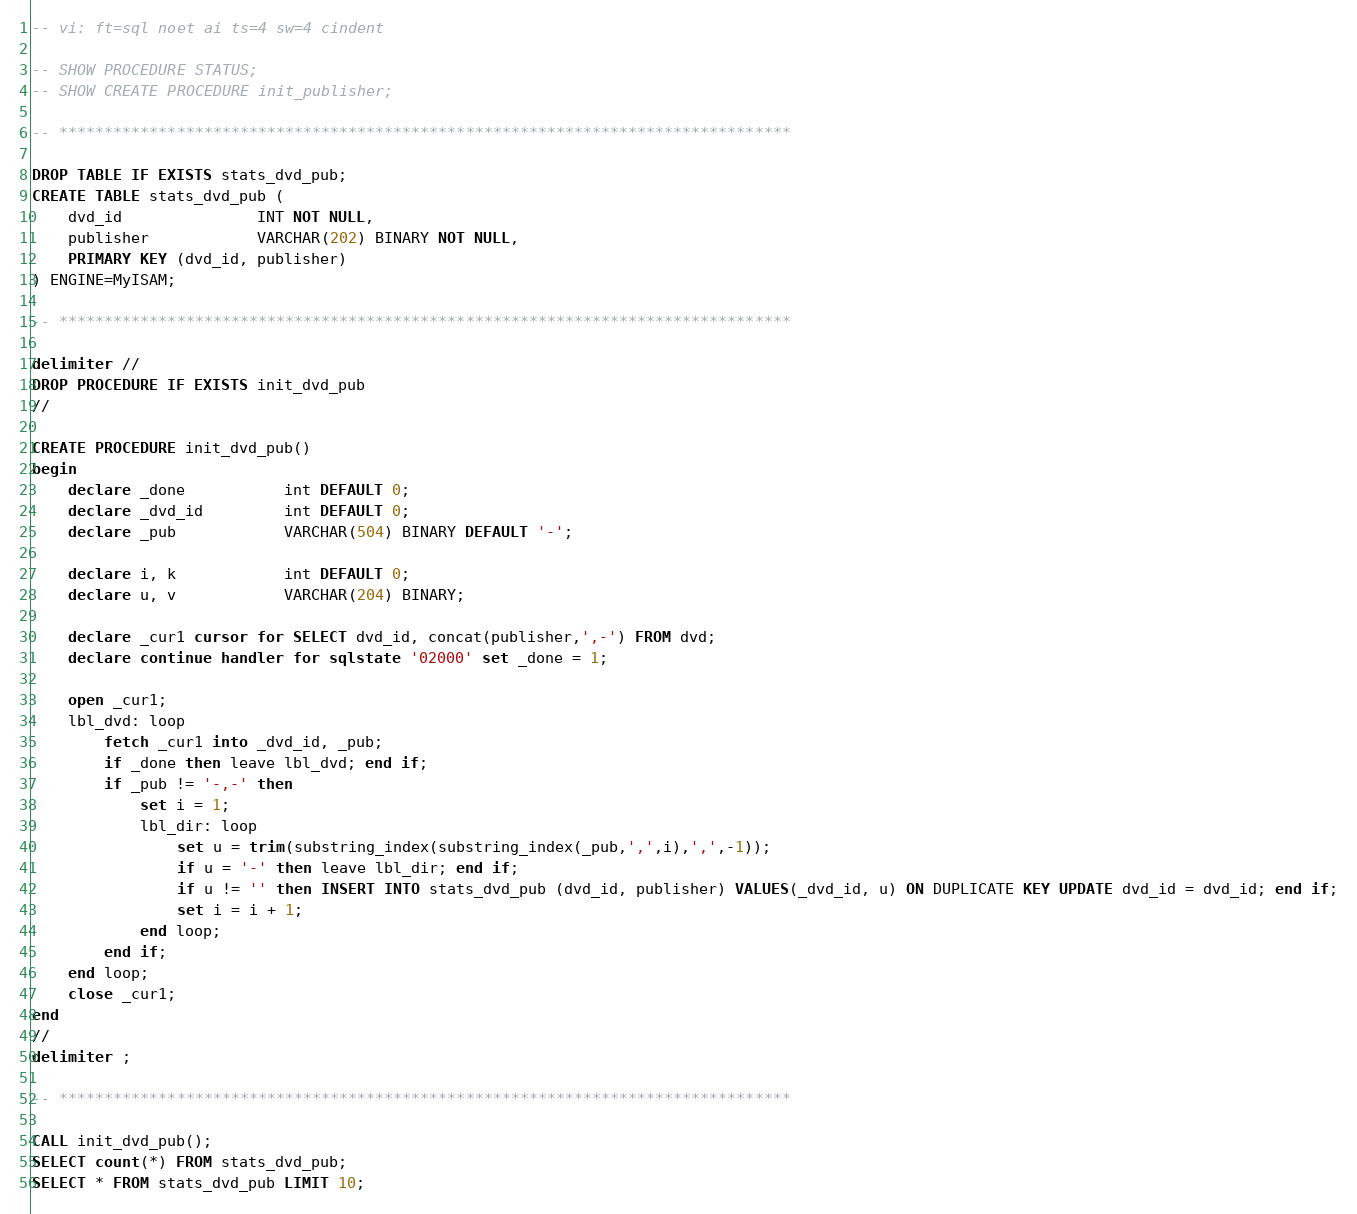Convert code to text. <code><loc_0><loc_0><loc_500><loc_500><_SQL_>-- vi: ft=sql noet ai ts=4 sw=4 cindent

-- SHOW PROCEDURE STATUS;
-- SHOW CREATE PROCEDURE init_publisher;

-- *********************************************************************************

DROP TABLE IF EXISTS stats_dvd_pub;
CREATE TABLE stats_dvd_pub (
    dvd_id               INT NOT NULL,
    publisher            VARCHAR(202) BINARY NOT NULL,
    PRIMARY KEY (dvd_id, publisher)
) ENGINE=MyISAM;

-- *********************************************************************************

delimiter //
DROP PROCEDURE IF EXISTS init_dvd_pub
//

CREATE PROCEDURE init_dvd_pub()
begin
    declare _done           int DEFAULT 0;
    declare _dvd_id         int DEFAULT 0;
    declare _pub            VARCHAR(504) BINARY DEFAULT '-';

    declare i, k            int DEFAULT 0;
    declare u, v            VARCHAR(204) BINARY;

    declare _cur1 cursor for SELECT dvd_id, concat(publisher,',-') FROM dvd;
    declare continue handler for sqlstate '02000' set _done = 1;

    open _cur1;
    lbl_dvd: loop
        fetch _cur1 into _dvd_id, _pub;
        if _done then leave lbl_dvd; end if;
        if _pub != '-,-' then
            set i = 1;
            lbl_dir: loop
                set u = trim(substring_index(substring_index(_pub,',',i),',',-1));
                if u = '-' then leave lbl_dir; end if;
				if u != '' then INSERT INTO stats_dvd_pub (dvd_id, publisher) VALUES(_dvd_id, u) ON DUPLICATE KEY UPDATE dvd_id = dvd_id; end if;
                set i = i + 1;
            end loop;
        end if;
	end loop;
    close _cur1;
end
//
delimiter ;

-- *********************************************************************************

CALL init_dvd_pub();
SELECT count(*) FROM stats_dvd_pub;
SELECT * FROM stats_dvd_pub LIMIT 10;

</code> 